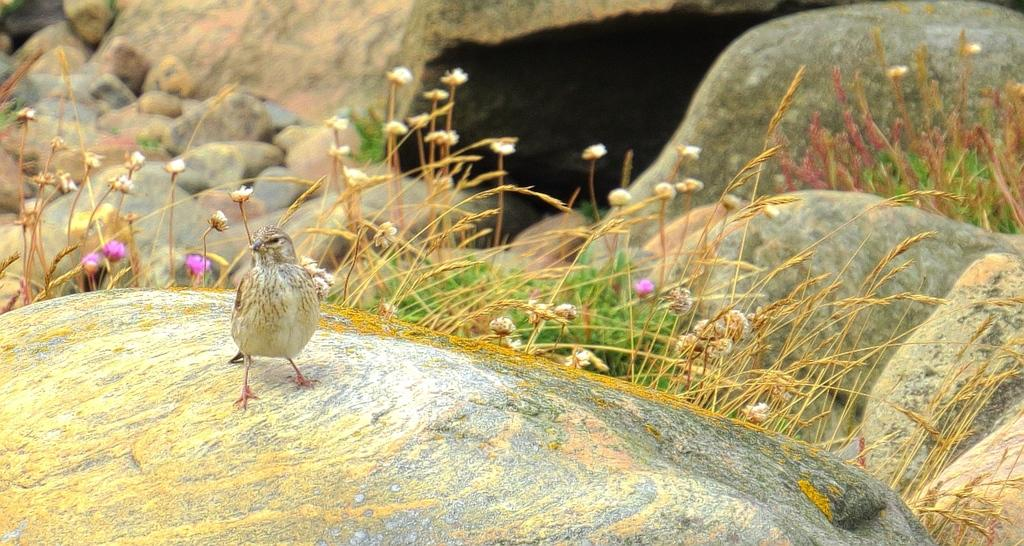What type of animal can be seen in the image? There is a bird in the image. What natural elements are present in the image? There are rocks, flowers, and grass in the image. What type of light source is illuminating the bird in the image? There is no specific light source mentioned or visible in the image, as it appears to be a natural scene with sunlight or ambient light. 